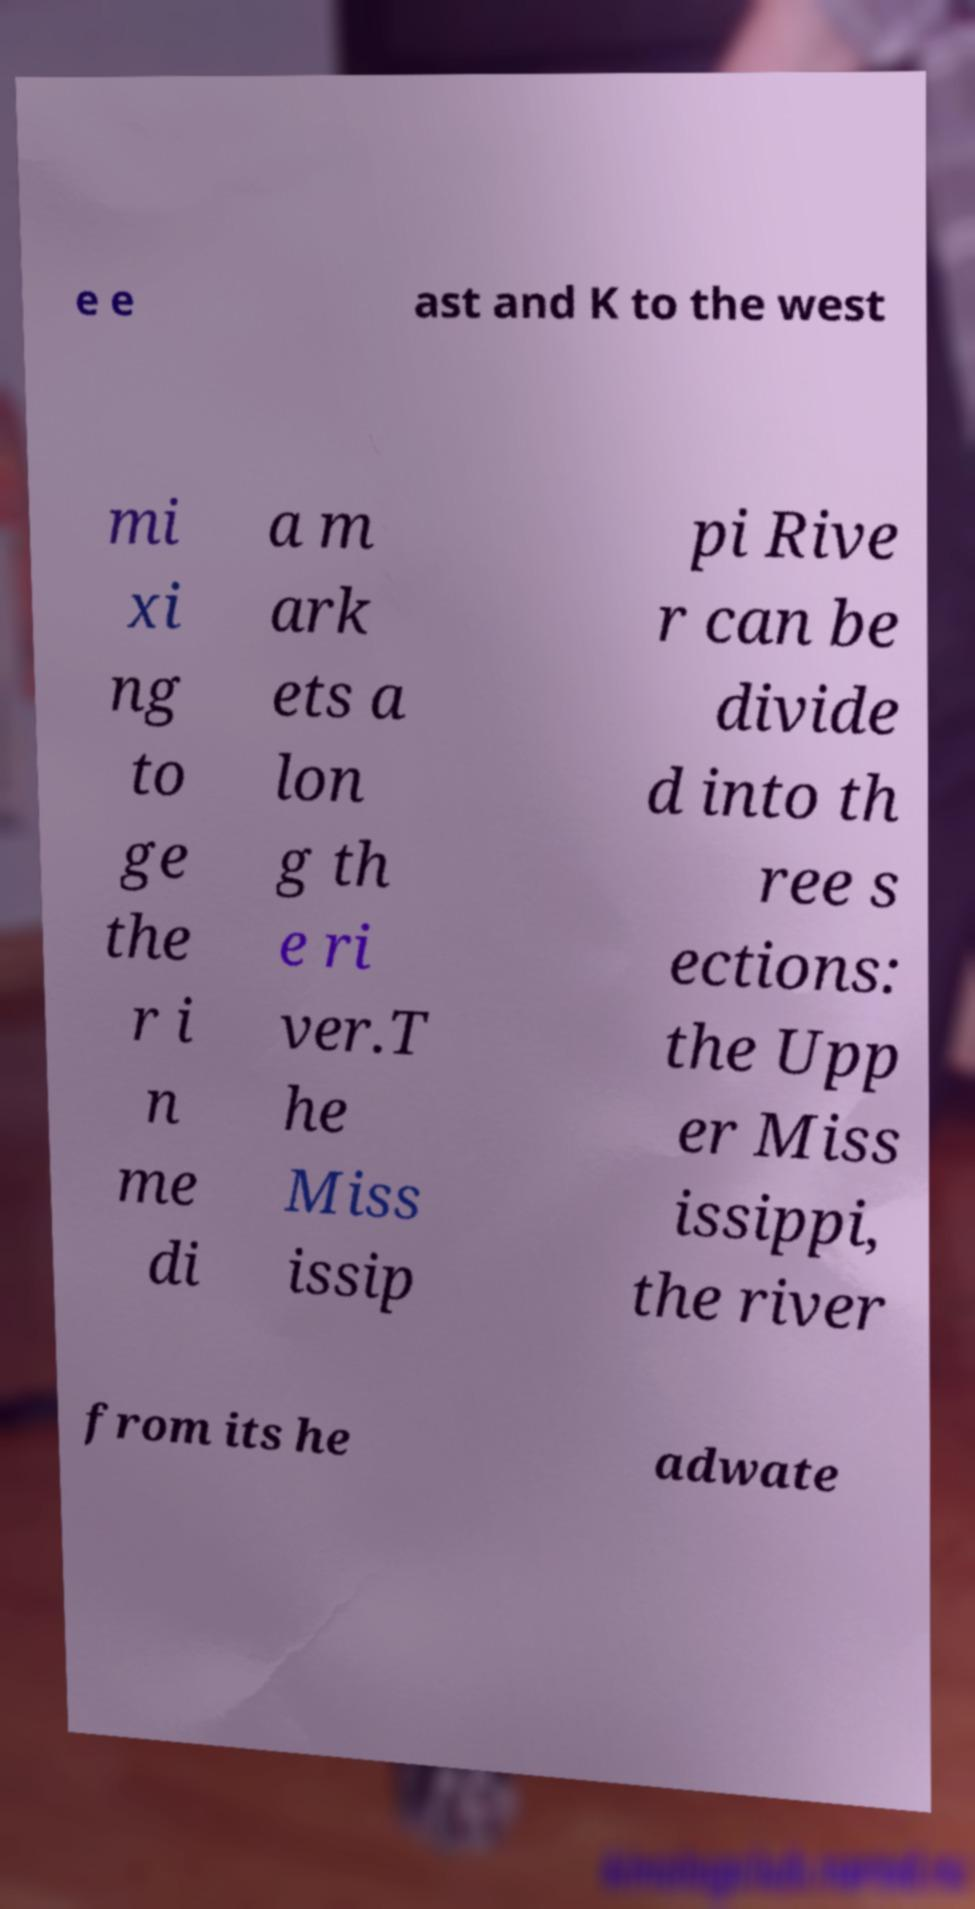There's text embedded in this image that I need extracted. Can you transcribe it verbatim? e e ast and K to the west mi xi ng to ge the r i n me di a m ark ets a lon g th e ri ver.T he Miss issip pi Rive r can be divide d into th ree s ections: the Upp er Miss issippi, the river from its he adwate 